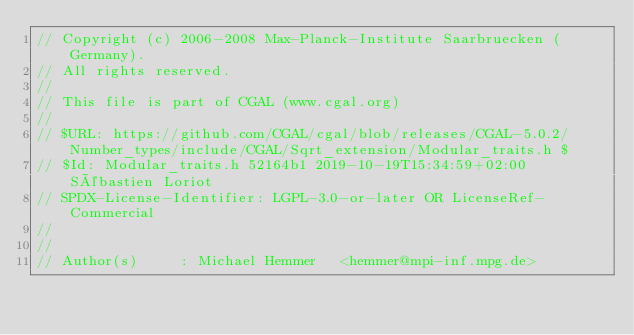Convert code to text. <code><loc_0><loc_0><loc_500><loc_500><_C_>// Copyright (c) 2006-2008 Max-Planck-Institute Saarbruecken (Germany).
// All rights reserved.
//
// This file is part of CGAL (www.cgal.org)
//
// $URL: https://github.com/CGAL/cgal/blob/releases/CGAL-5.0.2/Number_types/include/CGAL/Sqrt_extension/Modular_traits.h $
// $Id: Modular_traits.h 52164b1 2019-10-19T15:34:59+02:00 Sébastien Loriot
// SPDX-License-Identifier: LGPL-3.0-or-later OR LicenseRef-Commercial
//
//
// Author(s)     : Michael Hemmer   <hemmer@mpi-inf.mpg.de>

</code> 